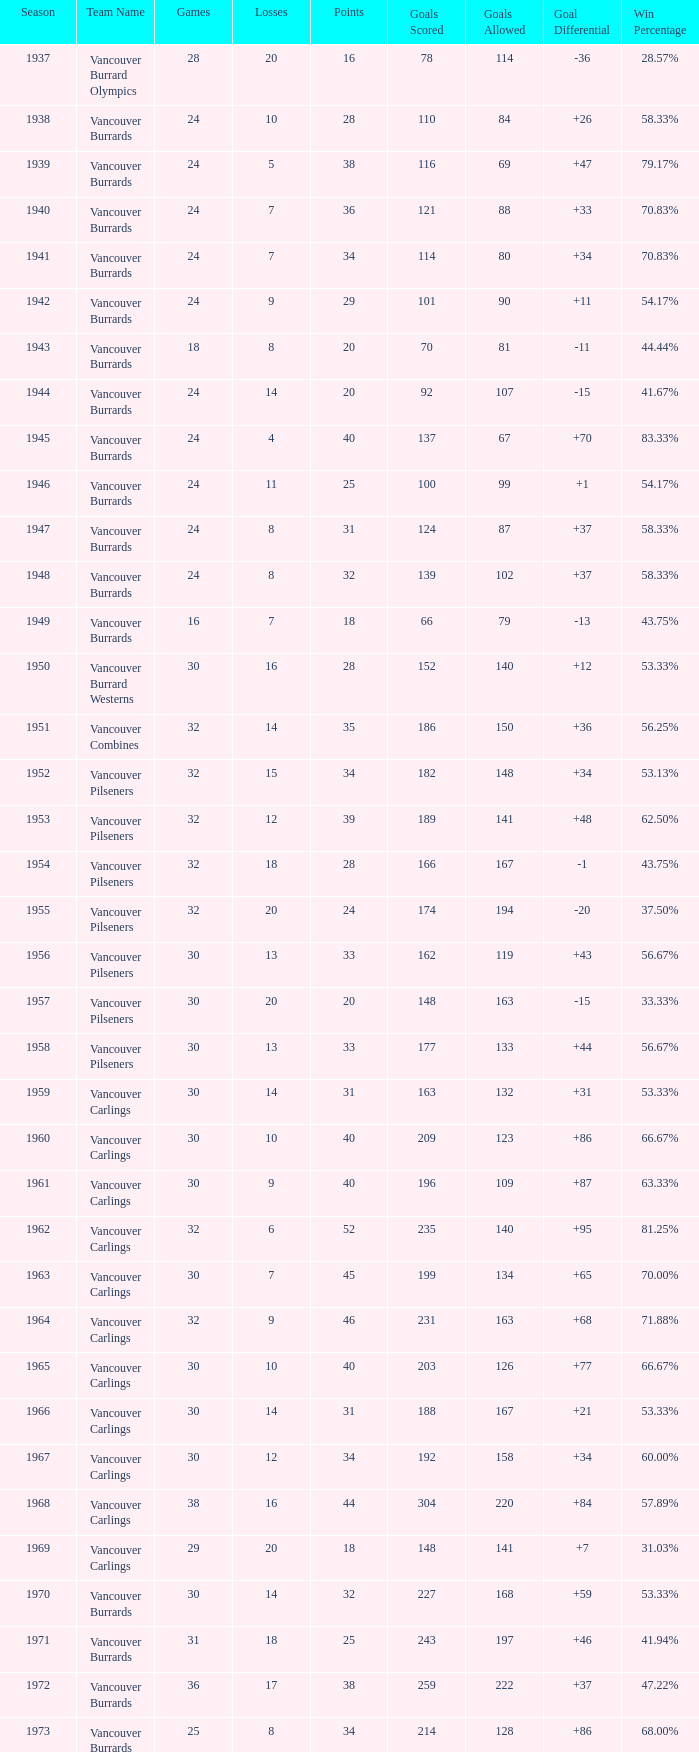What's the sum of points for the 1963 season when there are more than 30 games? None. 